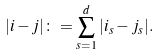<formula> <loc_0><loc_0><loc_500><loc_500>| i - j | \colon = \sum _ { s = 1 } ^ { d } | i _ { s } - j _ { s } | .</formula> 